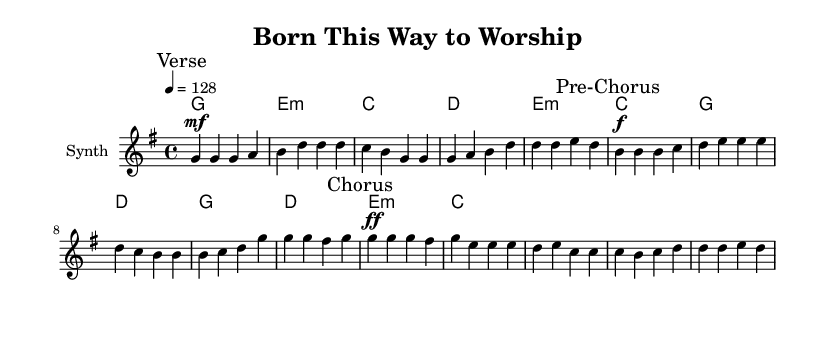What is the key signature of this music? The key signature indicates G major, as it has one sharp (F#). This can be determined by looking at the key signature indicated at the beginning of the staff.
Answer: G major What is the time signature of this music? The time signature is 4/4, which is shown at the beginning of the staff. This means there are four beats in a measure, and the quarter note receives one beat.
Answer: 4/4 What is the tempo marking for this piece? The tempo marking is 128 beats per minute, as indicated at the beginning of the score. This suggests a relatively upbeat pace suitable for dance-inspired worship music.
Answer: 128 How many measures are in the chorus section? The chorus section consists of four measures, which can be identified by counting the measures in the marked section labeled "Chorus."
Answer: 4 What dynamic level is indicated at the beginning of the pre-chorus? The dynamic level at the beginning of the pre-chorus is marked as forte (f), which means to play loudly. This is highlighted in the score right before the pre-chorus section.
Answer: forte What chord is played during the first measure of the verse? The chord played during the first measure of the verse is G. This is shown in the chord names aligned with the melody notes on the first measure of the verse.
Answer: G What is the relationship between the melody and harmony in the chorus? In the chorus, the melody's notes correspond to the harmony's chords, with the melody being largely based on the G chord, moving through the harmonic progression indicated by the written chords. Here, the chords support the melody during the climax of the song.
Answer: The melody fills the harmony 